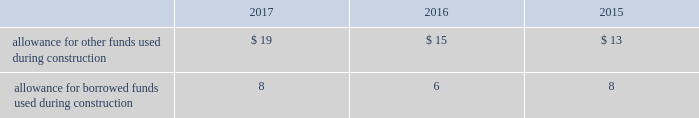Income taxes american water and its subsidiaries participate in a consolidated federal income tax return for u.s .
Tax purposes .
Members of the consolidated group are charged with the amount of federal income tax expense determined as if they filed separate returns .
Certain income and expense items are accounted for in different time periods for financial reporting than for income tax reporting purposes .
The company provides deferred income taxes on the difference between the tax basis of assets and liabilities and the amounts at which they are carried in the financial statements .
These deferred income taxes are based on the enacted tax rates expected to be in effect when these temporary differences are projected to reverse .
In addition , the regulated utility subsidiaries recognize regulatory assets and liabilities for the effect on revenues expected to be realized as the tax effects of temporary differences , previously flowed through to customers , reverse .
Investment tax credits have been deferred by the regulated utility subsidiaries and are being amortized to income over the average estimated service lives of the related assets .
The company recognizes accrued interest and penalties related to tax positions as a component of income tax expense and accounts for sales tax collected from customers and remitted to taxing authorities on a net basis .
See note 13 2014income taxes .
Allowance for funds used during construction afudc is a non-cash credit to income with a corresponding charge to utility plant that represents the cost of borrowed funds or a return on equity funds devoted to plant under construction .
The regulated utility subsidiaries record afudc to the extent permitted by the pucs .
The portion of afudc attributable to borrowed funds is shown as a reduction of interest , net in the accompanying consolidated statements of operations .
Any portion of afudc attributable to equity funds would be included in other income ( expenses ) in the accompanying consolidated statements of operations .
Afudc is summarized in the table for the years ended december 31: .
Environmental costs the company 2019s water and wastewater operations and the operations of its market-based businesses are subject to u.s .
Federal , state , local and foreign requirements relating to environmental protection , and as such , the company periodically becomes subject to environmental claims in the normal course of business .
Environmental expenditures that relate to current operations or provide a future benefit are expensed or capitalized as appropriate .
Remediation costs that relate to an existing condition caused by past operations are accrued , on an undiscounted basis , when it is probable that these costs will be incurred and can be reasonably estimated .
A conservation agreement entered into by a subsidiary of the company with the national oceanic and atmospheric administration in 2010 and amended in 2017 required the company to , among other provisions , implement certain measures to protect the steelhead trout and its habitat in the carmel river watershed in the state of california .
The company agreed to pay $ 1 million annually commencing in 2010 with the final payment being made in 2021 .
Remediation costs accrued amounted to $ 6 million and less than $ 1 million as of december 31 , 2017 and 2016 , respectively .
Derivative financial instruments the company uses derivative financial instruments for purposes of hedging exposures to fluctuations in interest rates .
These derivative contracts are entered into for periods consistent with the related underlying .
What was the combined amount of allowance for funds used in and funds borrowed in construction in 2016? 
Rationale: the combined amount of allowance of funds used and borrowed in any years is the sum of the separate amounts
Computations: (15 + 6)
Answer: 21.0. 